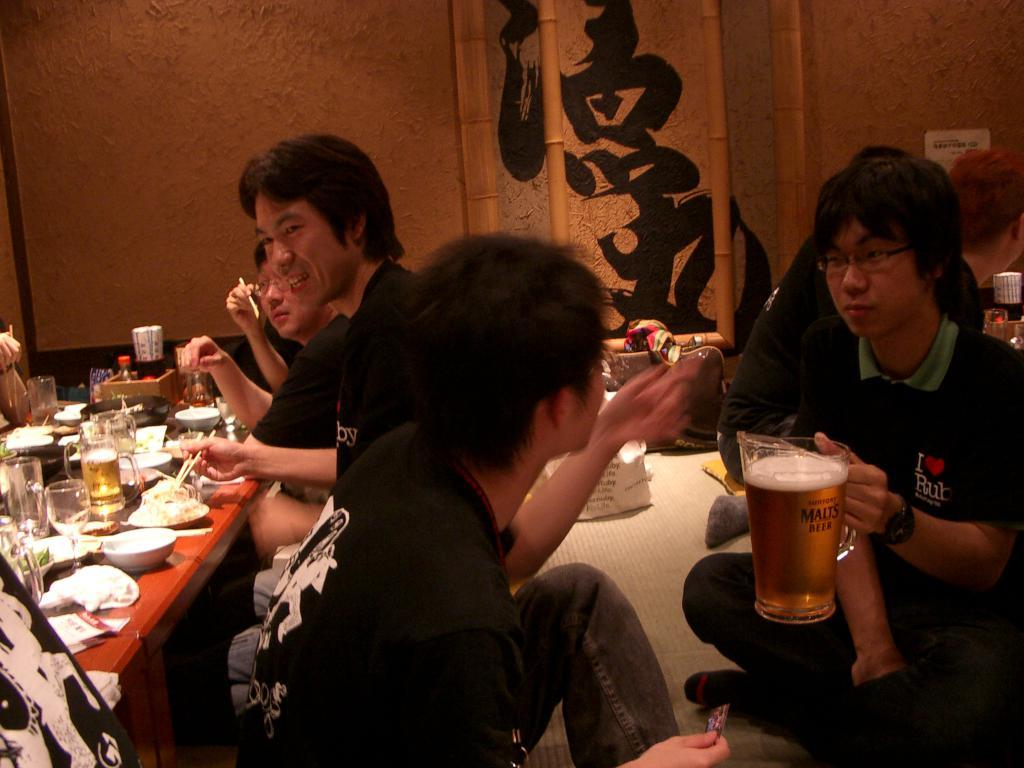What are the people in the image doing? There is a group of people seated in the image. What objects are on the table in the image? There are glasses, bowls, and food on the table. Can you describe the person holding a glass in his hand? A person is holding a beer glass in his hand. What type of cave can be seen in the background of the image? There is no cave present in the image; it features a group of people seated at a table with glasses, bowls, and food. 